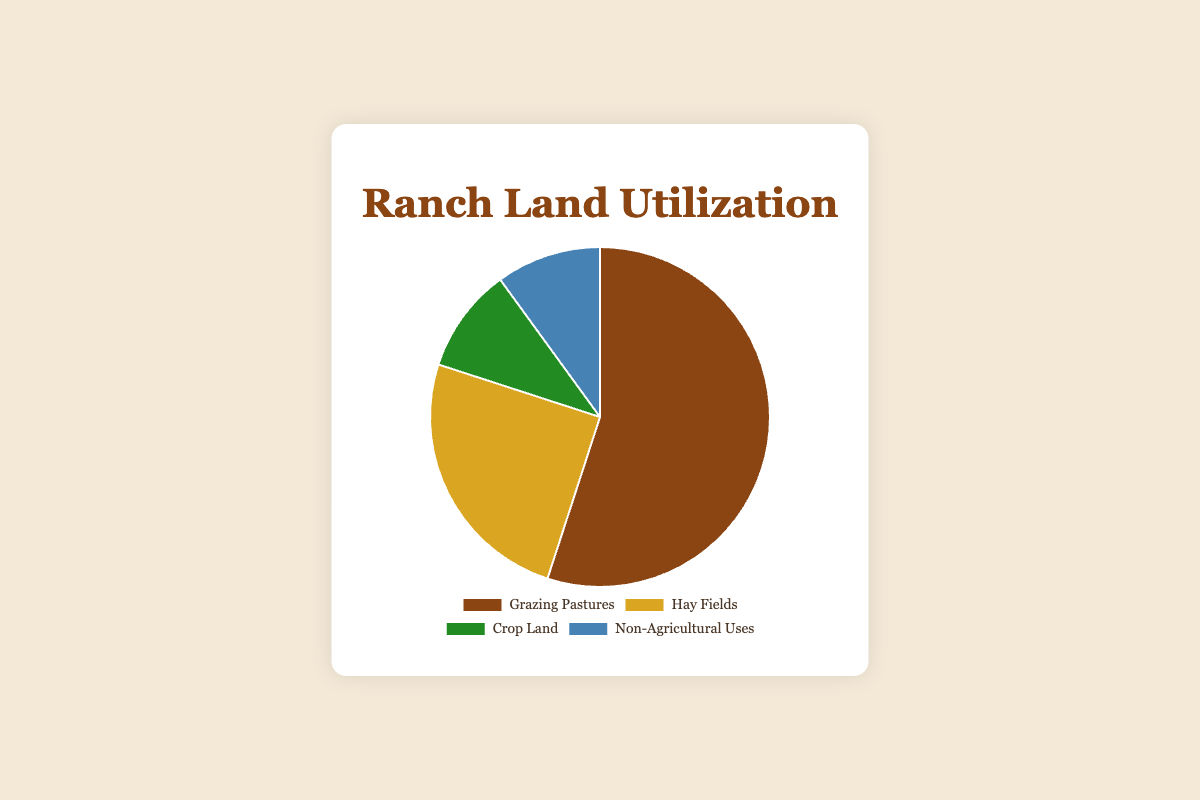What percentage of the ranch land is used for Grazing Pastures? The pie chart shows different land utilization categories with their respective percentages. Grazing Pastures is labeled directly on the chart as 55%.
Answer: 55% Which category uses the least amount of land on the ranch? By looking at the percentages on the pie chart, the categories for Crop Land and Non-Agricultural Uses are both marked with 10%, which are the smallest percentages.
Answer: Crop Land and Non-Agricultural Uses How much more land is used for Grazing Pastures compared to Hay Fields? Grazing Pastures use 55% of the land and Hay Fields use 25%. The difference is 55% - 25% = 30%.
Answer: 30% What is the combined percentage of land used for purposes other than grazing, i.e., Hay Fields, Crop Land, and Non-Agricultural Uses? Add the percentages of Hay Fields (25%), Crop Land (10%), and Non-Agricultural Uses (10%). The total is 25% + 10% + 10% = 45%.
Answer: 45% Which colors are associated with the Crop Land and Non-Agricultural Uses categories, respectively, in the chart? The pie chart visually represents Crop Land with green color and Non-Agricultural Uses with blue color, as per the listed colors in the data array.
Answer: Green for Crop Land and Blue for Non-Agricultural Uses If the ranch had a total area of 1000 acres, how many acres would be used for Hay Fields? If Hay Fields account for 25% of the ranch, calculate the actual area by multiplying 1000 acres by 0.25. Therefore, 1000 * 0.25 = 250 acres.
Answer: 250 acres Are the percentages for Crop Land and Non-Agricultural Uses the same or different? According to the pie chart, both Crop Land and Non-Agricultural Uses are each assigned 10%. Therefore, they are the same.
Answer: Same What is the difference in percentage between the land used for Grazing Pastures and Crop Land? Grazing Pastures use 55% of the land and Crop Land uses 10%. Calculate the difference: 55% - 10% = 45%.
Answer: 45% Which category dominates the land utilization on the ranch? Grazing Pastures has the largest percentage on the pie chart at 55%, indicating it is the dominant land use category.
Answer: Grazing Pastures 